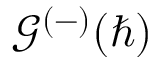<formula> <loc_0><loc_0><loc_500><loc_500>\mathcal { G } ^ { ( - ) } ( \hbar { ) }</formula> 